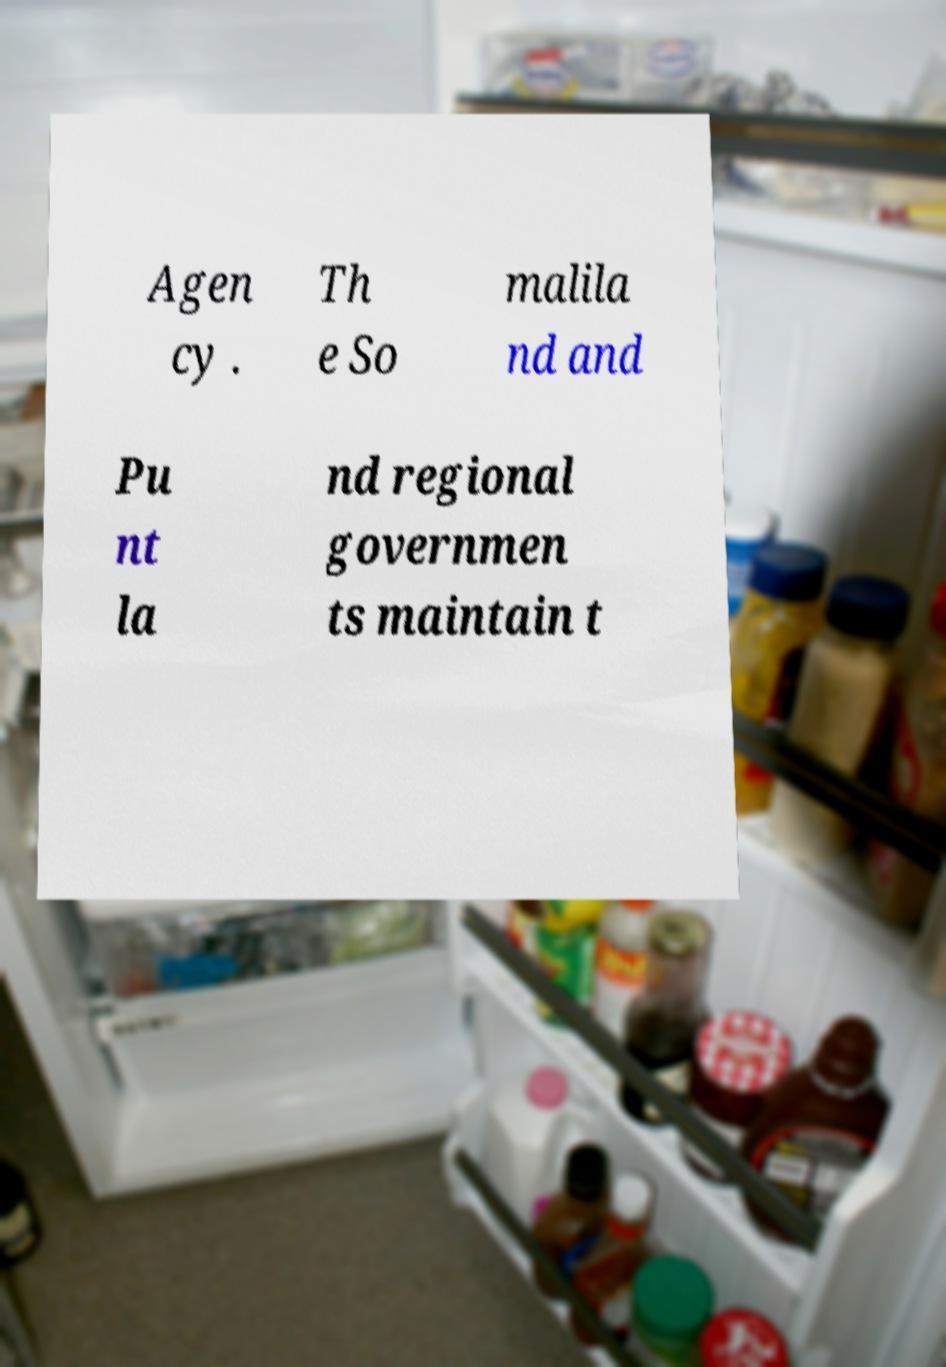Please read and relay the text visible in this image. What does it say? Agen cy . Th e So malila nd and Pu nt la nd regional governmen ts maintain t 